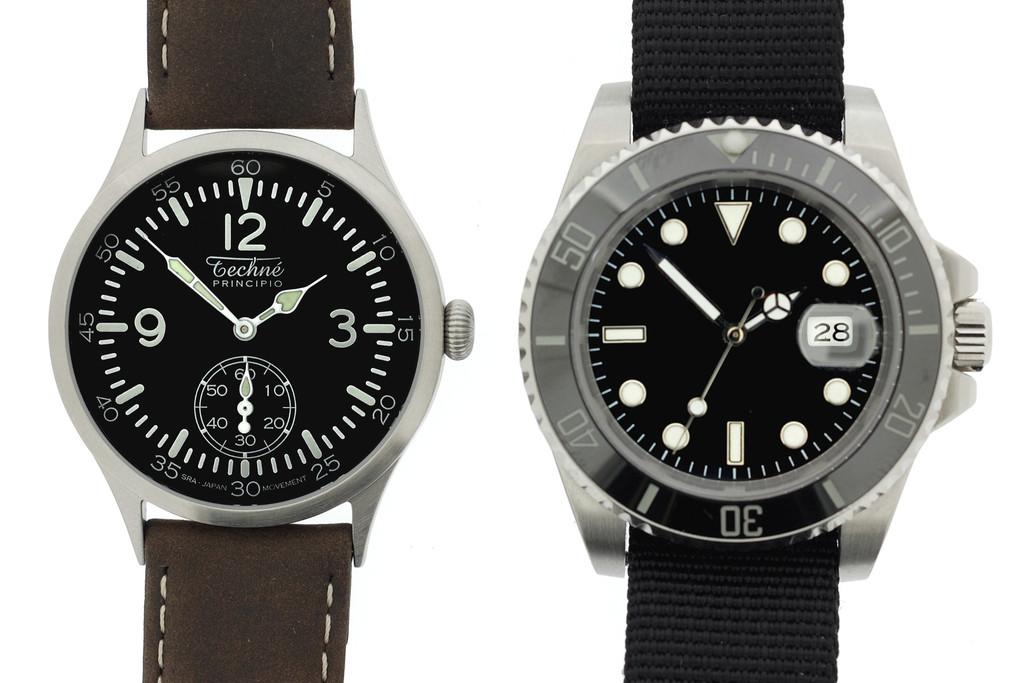What country is on the bottom of the watch face?
Your answer should be compact. Japan. What time is it on the watches?
Your answer should be very brief. 1:52. 